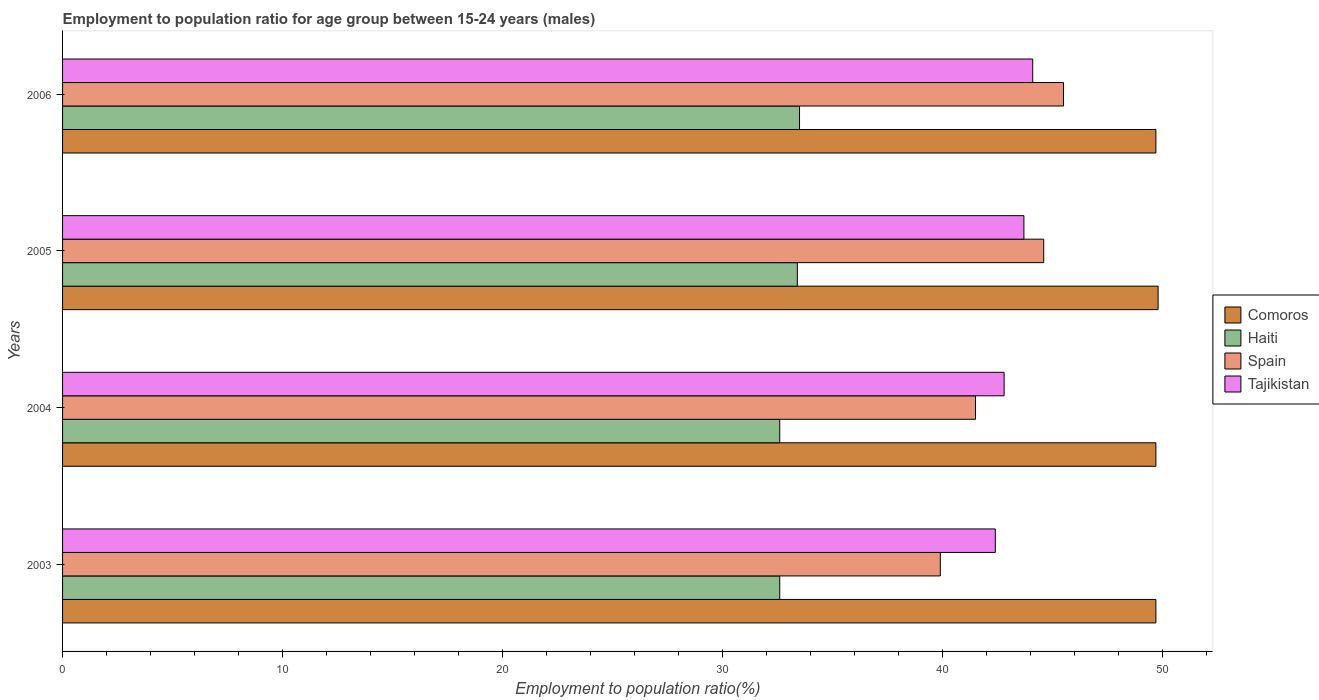Are the number of bars per tick equal to the number of legend labels?
Offer a terse response. Yes. How many bars are there on the 2nd tick from the top?
Ensure brevity in your answer.  4. What is the employment to population ratio in Haiti in 2006?
Give a very brief answer. 33.5. Across all years, what is the maximum employment to population ratio in Comoros?
Keep it short and to the point. 49.8. Across all years, what is the minimum employment to population ratio in Comoros?
Your answer should be compact. 49.7. In which year was the employment to population ratio in Spain maximum?
Give a very brief answer. 2006. In which year was the employment to population ratio in Haiti minimum?
Your answer should be compact. 2003. What is the total employment to population ratio in Comoros in the graph?
Keep it short and to the point. 198.9. What is the difference between the employment to population ratio in Haiti in 2003 and that in 2005?
Give a very brief answer. -0.8. What is the difference between the employment to population ratio in Spain in 2004 and the employment to population ratio in Comoros in 2003?
Offer a very short reply. -8.2. What is the average employment to population ratio in Tajikistan per year?
Make the answer very short. 43.25. In the year 2006, what is the difference between the employment to population ratio in Spain and employment to population ratio in Haiti?
Your answer should be compact. 12. In how many years, is the employment to population ratio in Tajikistan greater than 34 %?
Provide a short and direct response. 4. What is the ratio of the employment to population ratio in Comoros in 2005 to that in 2006?
Offer a very short reply. 1. Is the employment to population ratio in Comoros in 2003 less than that in 2004?
Offer a terse response. No. What is the difference between the highest and the second highest employment to population ratio in Tajikistan?
Make the answer very short. 0.4. What is the difference between the highest and the lowest employment to population ratio in Comoros?
Provide a succinct answer. 0.1. What does the 3rd bar from the top in 2005 represents?
Ensure brevity in your answer.  Haiti. Is it the case that in every year, the sum of the employment to population ratio in Spain and employment to population ratio in Haiti is greater than the employment to population ratio in Comoros?
Offer a terse response. Yes. How many bars are there?
Provide a short and direct response. 16. Are the values on the major ticks of X-axis written in scientific E-notation?
Make the answer very short. No. Does the graph contain grids?
Your response must be concise. No. How many legend labels are there?
Your answer should be compact. 4. What is the title of the graph?
Make the answer very short. Employment to population ratio for age group between 15-24 years (males). Does "Czech Republic" appear as one of the legend labels in the graph?
Make the answer very short. No. What is the Employment to population ratio(%) of Comoros in 2003?
Your answer should be compact. 49.7. What is the Employment to population ratio(%) in Haiti in 2003?
Keep it short and to the point. 32.6. What is the Employment to population ratio(%) of Spain in 2003?
Offer a terse response. 39.9. What is the Employment to population ratio(%) in Tajikistan in 2003?
Ensure brevity in your answer.  42.4. What is the Employment to population ratio(%) of Comoros in 2004?
Give a very brief answer. 49.7. What is the Employment to population ratio(%) in Haiti in 2004?
Offer a very short reply. 32.6. What is the Employment to population ratio(%) of Spain in 2004?
Offer a terse response. 41.5. What is the Employment to population ratio(%) in Tajikistan in 2004?
Offer a very short reply. 42.8. What is the Employment to population ratio(%) in Comoros in 2005?
Provide a succinct answer. 49.8. What is the Employment to population ratio(%) in Haiti in 2005?
Provide a short and direct response. 33.4. What is the Employment to population ratio(%) of Spain in 2005?
Keep it short and to the point. 44.6. What is the Employment to population ratio(%) of Tajikistan in 2005?
Provide a succinct answer. 43.7. What is the Employment to population ratio(%) in Comoros in 2006?
Your response must be concise. 49.7. What is the Employment to population ratio(%) of Haiti in 2006?
Ensure brevity in your answer.  33.5. What is the Employment to population ratio(%) in Spain in 2006?
Offer a very short reply. 45.5. What is the Employment to population ratio(%) in Tajikistan in 2006?
Offer a terse response. 44.1. Across all years, what is the maximum Employment to population ratio(%) in Comoros?
Your answer should be very brief. 49.8. Across all years, what is the maximum Employment to population ratio(%) of Haiti?
Your answer should be compact. 33.5. Across all years, what is the maximum Employment to population ratio(%) in Spain?
Give a very brief answer. 45.5. Across all years, what is the maximum Employment to population ratio(%) in Tajikistan?
Your answer should be very brief. 44.1. Across all years, what is the minimum Employment to population ratio(%) in Comoros?
Offer a terse response. 49.7. Across all years, what is the minimum Employment to population ratio(%) in Haiti?
Your answer should be very brief. 32.6. Across all years, what is the minimum Employment to population ratio(%) in Spain?
Provide a short and direct response. 39.9. Across all years, what is the minimum Employment to population ratio(%) in Tajikistan?
Keep it short and to the point. 42.4. What is the total Employment to population ratio(%) of Comoros in the graph?
Your response must be concise. 198.9. What is the total Employment to population ratio(%) in Haiti in the graph?
Your answer should be very brief. 132.1. What is the total Employment to population ratio(%) of Spain in the graph?
Provide a succinct answer. 171.5. What is the total Employment to population ratio(%) of Tajikistan in the graph?
Your answer should be compact. 173. What is the difference between the Employment to population ratio(%) in Comoros in 2003 and that in 2004?
Offer a terse response. 0. What is the difference between the Employment to population ratio(%) of Haiti in 2003 and that in 2004?
Make the answer very short. 0. What is the difference between the Employment to population ratio(%) of Tajikistan in 2003 and that in 2004?
Provide a succinct answer. -0.4. What is the difference between the Employment to population ratio(%) of Comoros in 2003 and that in 2005?
Ensure brevity in your answer.  -0.1. What is the difference between the Employment to population ratio(%) in Haiti in 2003 and that in 2005?
Provide a short and direct response. -0.8. What is the difference between the Employment to population ratio(%) in Spain in 2003 and that in 2005?
Your answer should be very brief. -4.7. What is the difference between the Employment to population ratio(%) of Haiti in 2004 and that in 2005?
Your answer should be very brief. -0.8. What is the difference between the Employment to population ratio(%) in Spain in 2004 and that in 2005?
Provide a succinct answer. -3.1. What is the difference between the Employment to population ratio(%) of Haiti in 2004 and that in 2006?
Provide a short and direct response. -0.9. What is the difference between the Employment to population ratio(%) of Tajikistan in 2004 and that in 2006?
Offer a terse response. -1.3. What is the difference between the Employment to population ratio(%) of Comoros in 2005 and that in 2006?
Ensure brevity in your answer.  0.1. What is the difference between the Employment to population ratio(%) in Haiti in 2005 and that in 2006?
Provide a succinct answer. -0.1. What is the difference between the Employment to population ratio(%) of Haiti in 2003 and the Employment to population ratio(%) of Spain in 2004?
Give a very brief answer. -8.9. What is the difference between the Employment to population ratio(%) in Comoros in 2003 and the Employment to population ratio(%) in Haiti in 2005?
Provide a short and direct response. 16.3. What is the difference between the Employment to population ratio(%) in Comoros in 2003 and the Employment to population ratio(%) in Spain in 2005?
Give a very brief answer. 5.1. What is the difference between the Employment to population ratio(%) in Comoros in 2003 and the Employment to population ratio(%) in Tajikistan in 2005?
Keep it short and to the point. 6. What is the difference between the Employment to population ratio(%) of Comoros in 2003 and the Employment to population ratio(%) of Haiti in 2006?
Keep it short and to the point. 16.2. What is the difference between the Employment to population ratio(%) of Comoros in 2003 and the Employment to population ratio(%) of Tajikistan in 2006?
Provide a succinct answer. 5.6. What is the difference between the Employment to population ratio(%) in Haiti in 2003 and the Employment to population ratio(%) in Spain in 2006?
Provide a short and direct response. -12.9. What is the difference between the Employment to population ratio(%) in Haiti in 2003 and the Employment to population ratio(%) in Tajikistan in 2006?
Give a very brief answer. -11.5. What is the difference between the Employment to population ratio(%) of Comoros in 2004 and the Employment to population ratio(%) of Haiti in 2005?
Ensure brevity in your answer.  16.3. What is the difference between the Employment to population ratio(%) in Comoros in 2004 and the Employment to population ratio(%) in Spain in 2006?
Your answer should be very brief. 4.2. What is the difference between the Employment to population ratio(%) of Comoros in 2004 and the Employment to population ratio(%) of Tajikistan in 2006?
Keep it short and to the point. 5.6. What is the difference between the Employment to population ratio(%) of Haiti in 2004 and the Employment to population ratio(%) of Tajikistan in 2006?
Your response must be concise. -11.5. What is the difference between the Employment to population ratio(%) in Comoros in 2005 and the Employment to population ratio(%) in Spain in 2006?
Give a very brief answer. 4.3. What is the difference between the Employment to population ratio(%) in Comoros in 2005 and the Employment to population ratio(%) in Tajikistan in 2006?
Provide a short and direct response. 5.7. What is the difference between the Employment to population ratio(%) of Haiti in 2005 and the Employment to population ratio(%) of Spain in 2006?
Your answer should be very brief. -12.1. What is the difference between the Employment to population ratio(%) of Haiti in 2005 and the Employment to population ratio(%) of Tajikistan in 2006?
Your response must be concise. -10.7. What is the difference between the Employment to population ratio(%) of Spain in 2005 and the Employment to population ratio(%) of Tajikistan in 2006?
Offer a terse response. 0.5. What is the average Employment to population ratio(%) in Comoros per year?
Your answer should be very brief. 49.73. What is the average Employment to population ratio(%) of Haiti per year?
Ensure brevity in your answer.  33.02. What is the average Employment to population ratio(%) in Spain per year?
Provide a succinct answer. 42.88. What is the average Employment to population ratio(%) of Tajikistan per year?
Offer a very short reply. 43.25. In the year 2003, what is the difference between the Employment to population ratio(%) in Haiti and Employment to population ratio(%) in Spain?
Make the answer very short. -7.3. In the year 2004, what is the difference between the Employment to population ratio(%) in Comoros and Employment to population ratio(%) in Haiti?
Provide a short and direct response. 17.1. In the year 2004, what is the difference between the Employment to population ratio(%) of Haiti and Employment to population ratio(%) of Spain?
Make the answer very short. -8.9. In the year 2004, what is the difference between the Employment to population ratio(%) in Haiti and Employment to population ratio(%) in Tajikistan?
Offer a terse response. -10.2. In the year 2005, what is the difference between the Employment to population ratio(%) in Comoros and Employment to population ratio(%) in Tajikistan?
Give a very brief answer. 6.1. In the year 2005, what is the difference between the Employment to population ratio(%) of Haiti and Employment to population ratio(%) of Spain?
Offer a very short reply. -11.2. In the year 2005, what is the difference between the Employment to population ratio(%) of Haiti and Employment to population ratio(%) of Tajikistan?
Keep it short and to the point. -10.3. In the year 2006, what is the difference between the Employment to population ratio(%) of Comoros and Employment to population ratio(%) of Spain?
Keep it short and to the point. 4.2. In the year 2006, what is the difference between the Employment to population ratio(%) of Haiti and Employment to population ratio(%) of Spain?
Give a very brief answer. -12. What is the ratio of the Employment to population ratio(%) in Comoros in 2003 to that in 2004?
Keep it short and to the point. 1. What is the ratio of the Employment to population ratio(%) of Spain in 2003 to that in 2004?
Ensure brevity in your answer.  0.96. What is the ratio of the Employment to population ratio(%) in Comoros in 2003 to that in 2005?
Keep it short and to the point. 1. What is the ratio of the Employment to population ratio(%) in Haiti in 2003 to that in 2005?
Keep it short and to the point. 0.98. What is the ratio of the Employment to population ratio(%) of Spain in 2003 to that in 2005?
Provide a short and direct response. 0.89. What is the ratio of the Employment to population ratio(%) in Tajikistan in 2003 to that in 2005?
Ensure brevity in your answer.  0.97. What is the ratio of the Employment to population ratio(%) of Haiti in 2003 to that in 2006?
Your response must be concise. 0.97. What is the ratio of the Employment to population ratio(%) in Spain in 2003 to that in 2006?
Make the answer very short. 0.88. What is the ratio of the Employment to population ratio(%) of Tajikistan in 2003 to that in 2006?
Your response must be concise. 0.96. What is the ratio of the Employment to population ratio(%) in Spain in 2004 to that in 2005?
Offer a terse response. 0.93. What is the ratio of the Employment to population ratio(%) of Tajikistan in 2004 to that in 2005?
Ensure brevity in your answer.  0.98. What is the ratio of the Employment to population ratio(%) of Comoros in 2004 to that in 2006?
Your answer should be very brief. 1. What is the ratio of the Employment to population ratio(%) of Haiti in 2004 to that in 2006?
Keep it short and to the point. 0.97. What is the ratio of the Employment to population ratio(%) in Spain in 2004 to that in 2006?
Give a very brief answer. 0.91. What is the ratio of the Employment to population ratio(%) in Tajikistan in 2004 to that in 2006?
Provide a short and direct response. 0.97. What is the ratio of the Employment to population ratio(%) in Haiti in 2005 to that in 2006?
Provide a short and direct response. 1. What is the ratio of the Employment to population ratio(%) in Spain in 2005 to that in 2006?
Ensure brevity in your answer.  0.98. What is the ratio of the Employment to population ratio(%) in Tajikistan in 2005 to that in 2006?
Give a very brief answer. 0.99. What is the difference between the highest and the second highest Employment to population ratio(%) of Haiti?
Your response must be concise. 0.1. What is the difference between the highest and the lowest Employment to population ratio(%) of Haiti?
Offer a very short reply. 0.9. 